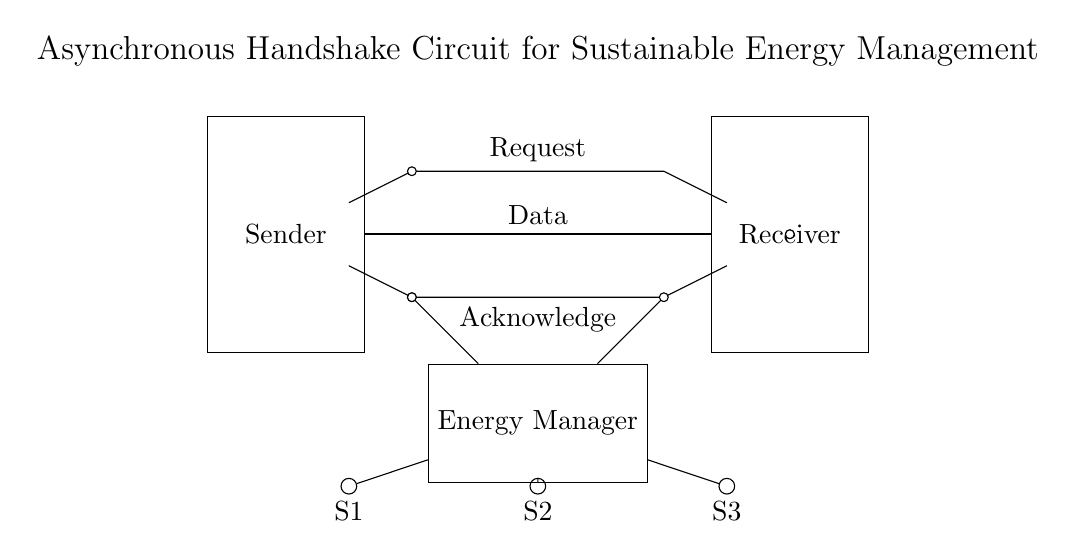What components are present in the sender block? The sender block contains the request and acknowledge lines that connect to the receiver. It also has a data bus that transfers data. The request and acknowledge lines form the asynchronous handshake mechanism.
Answer: request, acknowledge, data bus What is the purpose of the energy manager in this circuit? The energy manager receives input from the sensors and coordinates energy usage based on the data collected. It is a crucial component for sustainable energy management, optimizing energy consumption within smart buildings.
Answer: energy optimization How many sensors are connected to the energy manager? There are three sensors connected to the energy manager, identified as S1, S2, and S3. They feed data to the energy manager, allowing it to assess and manage energy consumption.
Answer: three What type of communication does this circuit use between sender and receiver? The circuit uses asynchronous communication, characterized by the handshake signals (request and acknowledge). This communication method ensures that data is transmitted without clock synchronization, which is essential for efficient operation in smart buildings.
Answer: asynchronous What do the labels 'Request' and 'Acknowledge' signify in this circuit? 'Request' signifies a signal sent from the sender to indicate that data is ready to be sent. 'Acknowledge' is a response signal from the receiver confirming that it has received the data correctly. This exchange is part of the asynchronous handshake protocol.
Answer: signal exchange 